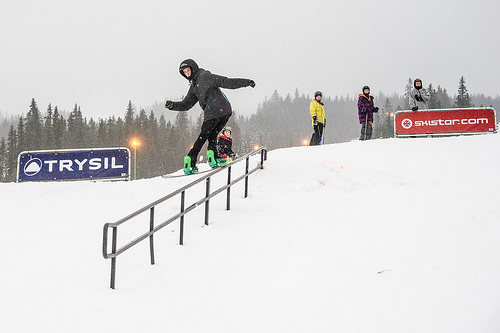On which side of the picture are the pine trees? The pine trees are mainly situated on the left side of the picture, creating a natural winter frame. 